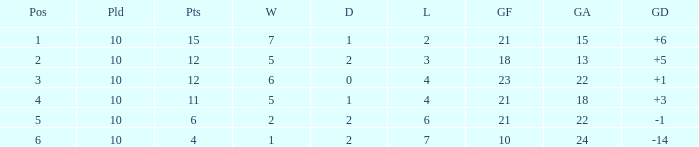Could you parse the entire table as a dict? {'header': ['Pos', 'Pld', 'Pts', 'W', 'D', 'L', 'GF', 'GA', 'GD'], 'rows': [['1', '10', '15', '7', '1', '2', '21', '15', '+6'], ['2', '10', '12', '5', '2', '3', '18', '13', '+5'], ['3', '10', '12', '6', '0', '4', '23', '22', '+1'], ['4', '10', '11', '5', '1', '4', '21', '18', '+3'], ['5', '10', '6', '2', '2', '6', '21', '22', '-1'], ['6', '10', '4', '1', '2', '7', '10', '24', '-14']]} Can you tell me the sum of Goals against that has the Goals for larger than 10, and the Position of 3, and the Wins smaller than 6? None. 